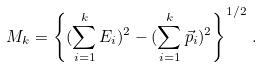<formula> <loc_0><loc_0><loc_500><loc_500>M _ { k } = \left \{ ( \sum _ { i = 1 } ^ { k } E _ { i } ) ^ { 2 } - ( \sum _ { i = 1 } ^ { k } { \vec { p } } _ { i } ) ^ { 2 } \right \} ^ { 1 / 2 } \, .</formula> 